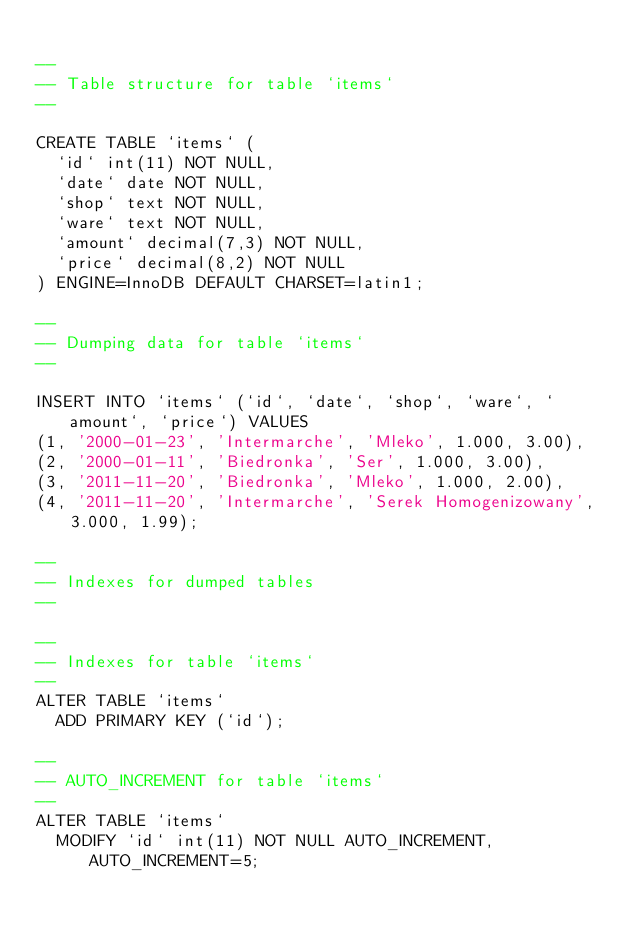Convert code to text. <code><loc_0><loc_0><loc_500><loc_500><_SQL_>
--
-- Table structure for table `items`
--

CREATE TABLE `items` (
  `id` int(11) NOT NULL,
  `date` date NOT NULL,
  `shop` text NOT NULL,
  `ware` text NOT NULL,
  `amount` decimal(7,3) NOT NULL,
  `price` decimal(8,2) NOT NULL
) ENGINE=InnoDB DEFAULT CHARSET=latin1;

--
-- Dumping data for table `items`
--

INSERT INTO `items` (`id`, `date`, `shop`, `ware`, `amount`, `price`) VALUES
(1, '2000-01-23', 'Intermarche', 'Mleko', 1.000, 3.00),
(2, '2000-01-11', 'Biedronka', 'Ser', 1.000, 3.00),
(3, '2011-11-20', 'Biedronka', 'Mleko', 1.000, 2.00),
(4, '2011-11-20', 'Intermarche', 'Serek Homogenizowany', 3.000, 1.99);

--
-- Indexes for dumped tables
--

--
-- Indexes for table `items`
--
ALTER TABLE `items`
  ADD PRIMARY KEY (`id`);

--
-- AUTO_INCREMENT for table `items`
--
ALTER TABLE `items`
  MODIFY `id` int(11) NOT NULL AUTO_INCREMENT, AUTO_INCREMENT=5;
</code> 